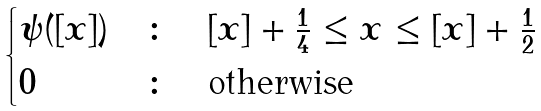Convert formula to latex. <formula><loc_0><loc_0><loc_500><loc_500>\begin{cases} \psi ( [ x ] ) & \colon \quad [ x ] + \frac { 1 } { 4 } \leq x \leq [ x ] + \frac { 1 } { 2 } \\ 0 & \colon \quad \text {otherwise} \end{cases}</formula> 